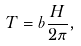<formula> <loc_0><loc_0><loc_500><loc_500>T = b \frac { H } { 2 \pi } ,</formula> 